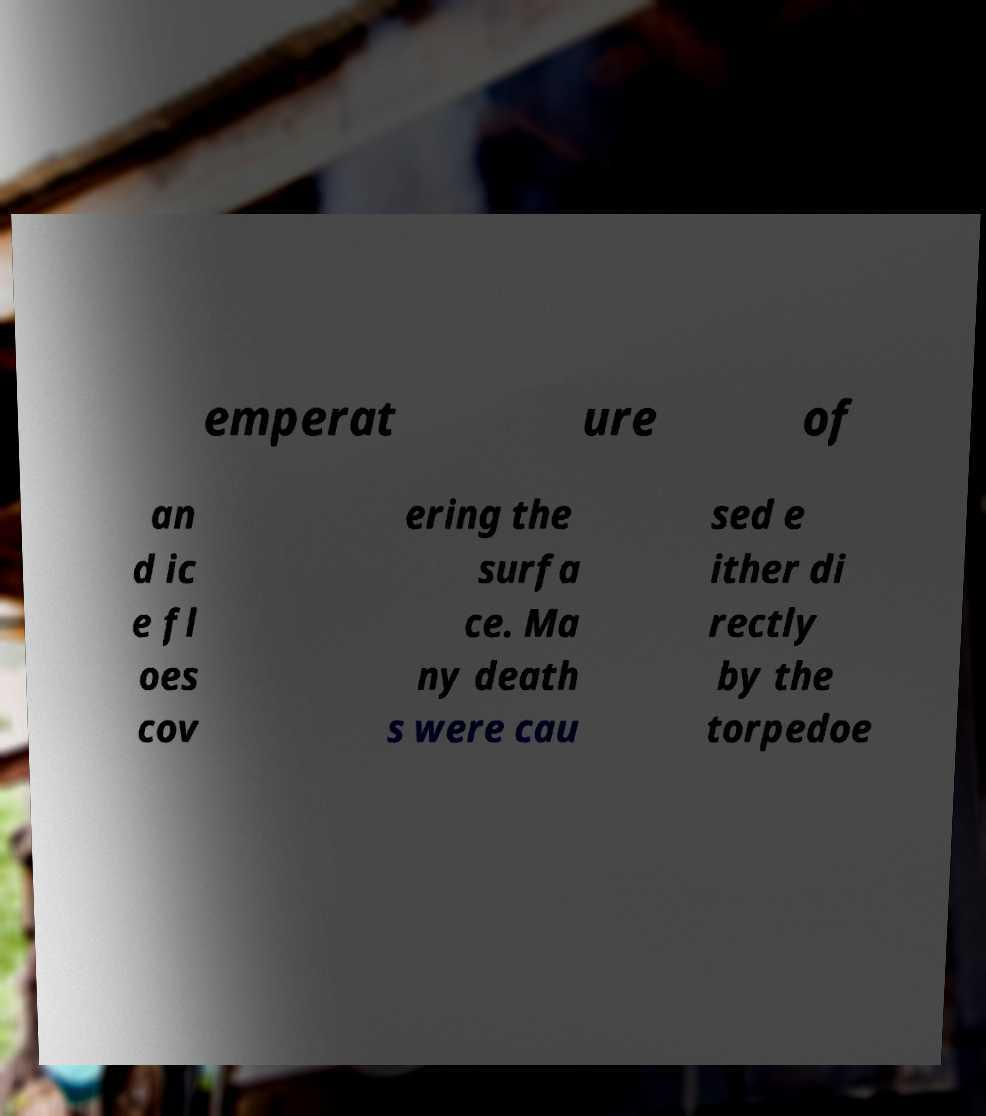Could you assist in decoding the text presented in this image and type it out clearly? emperat ure of an d ic e fl oes cov ering the surfa ce. Ma ny death s were cau sed e ither di rectly by the torpedoe 